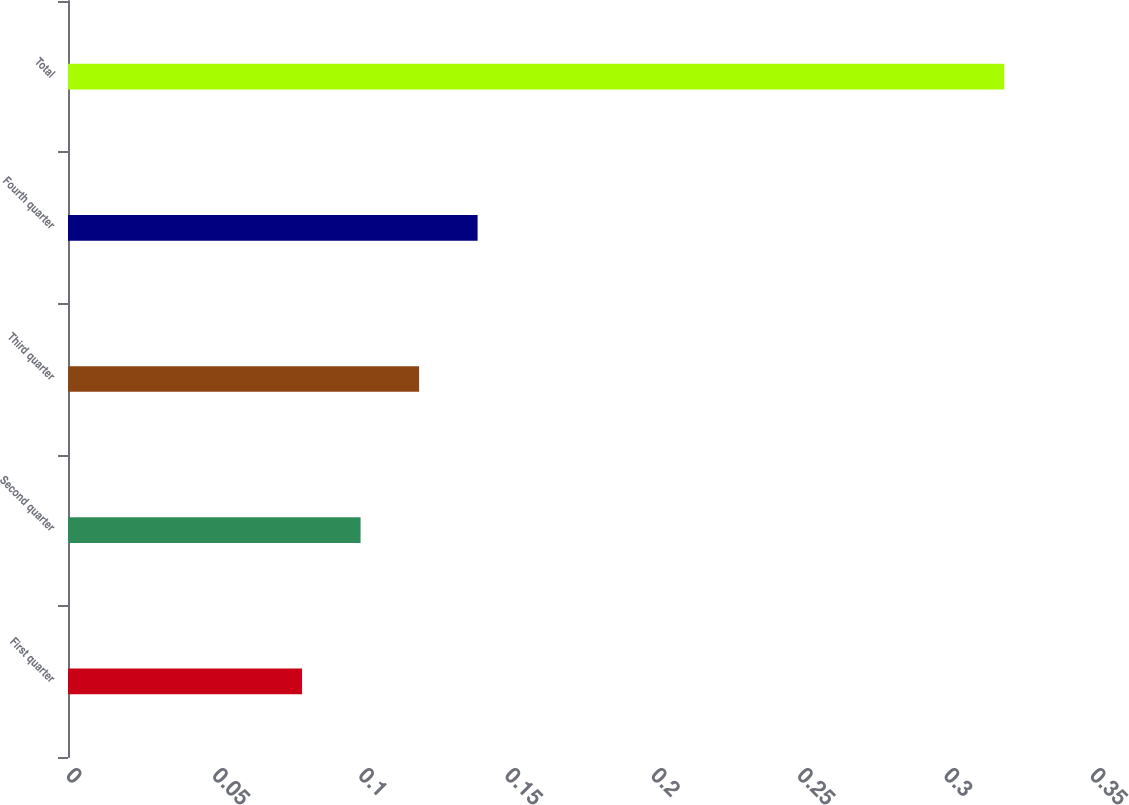Convert chart to OTSL. <chart><loc_0><loc_0><loc_500><loc_500><bar_chart><fcel>First quarter<fcel>Second quarter<fcel>Third quarter<fcel>Fourth quarter<fcel>Total<nl><fcel>0.08<fcel>0.1<fcel>0.12<fcel>0.14<fcel>0.32<nl></chart> 